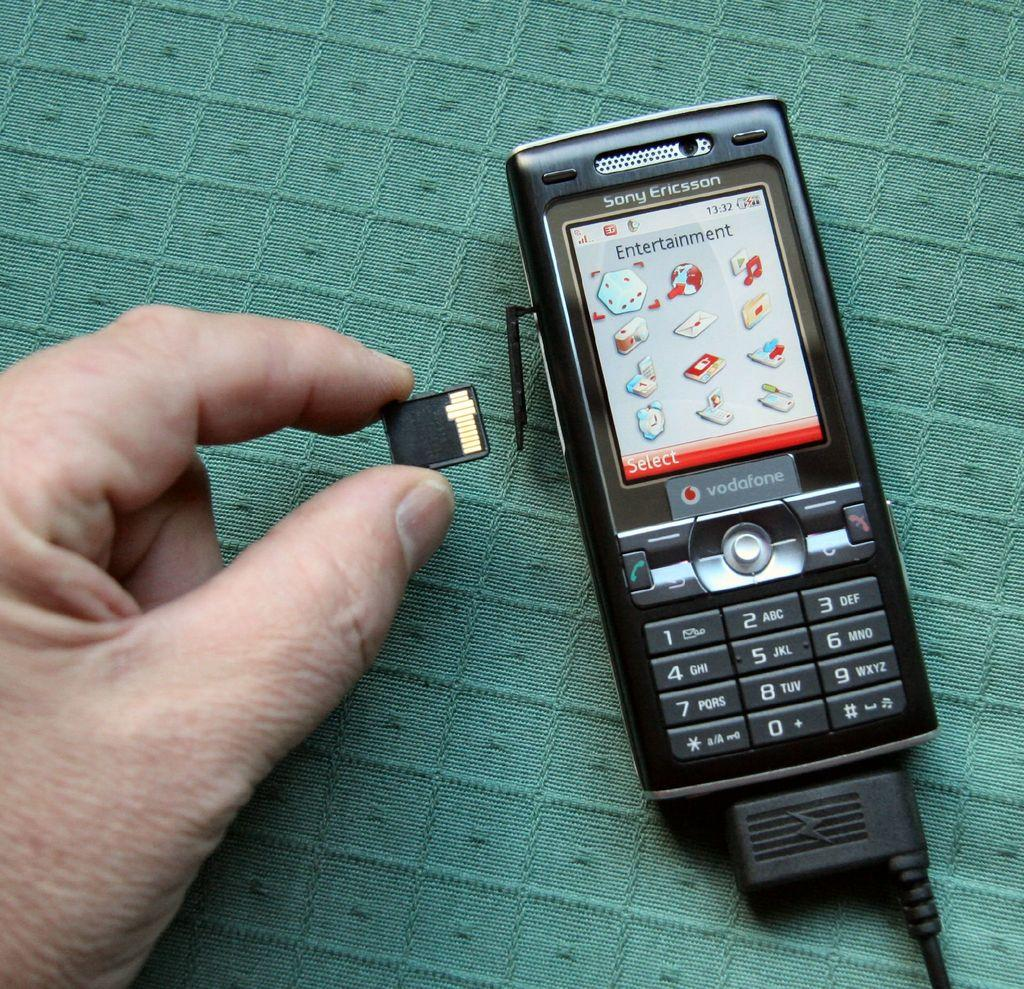<image>
Create a compact narrative representing the image presented. A Sony Ericsson phone is displaying the entertainment menu. 